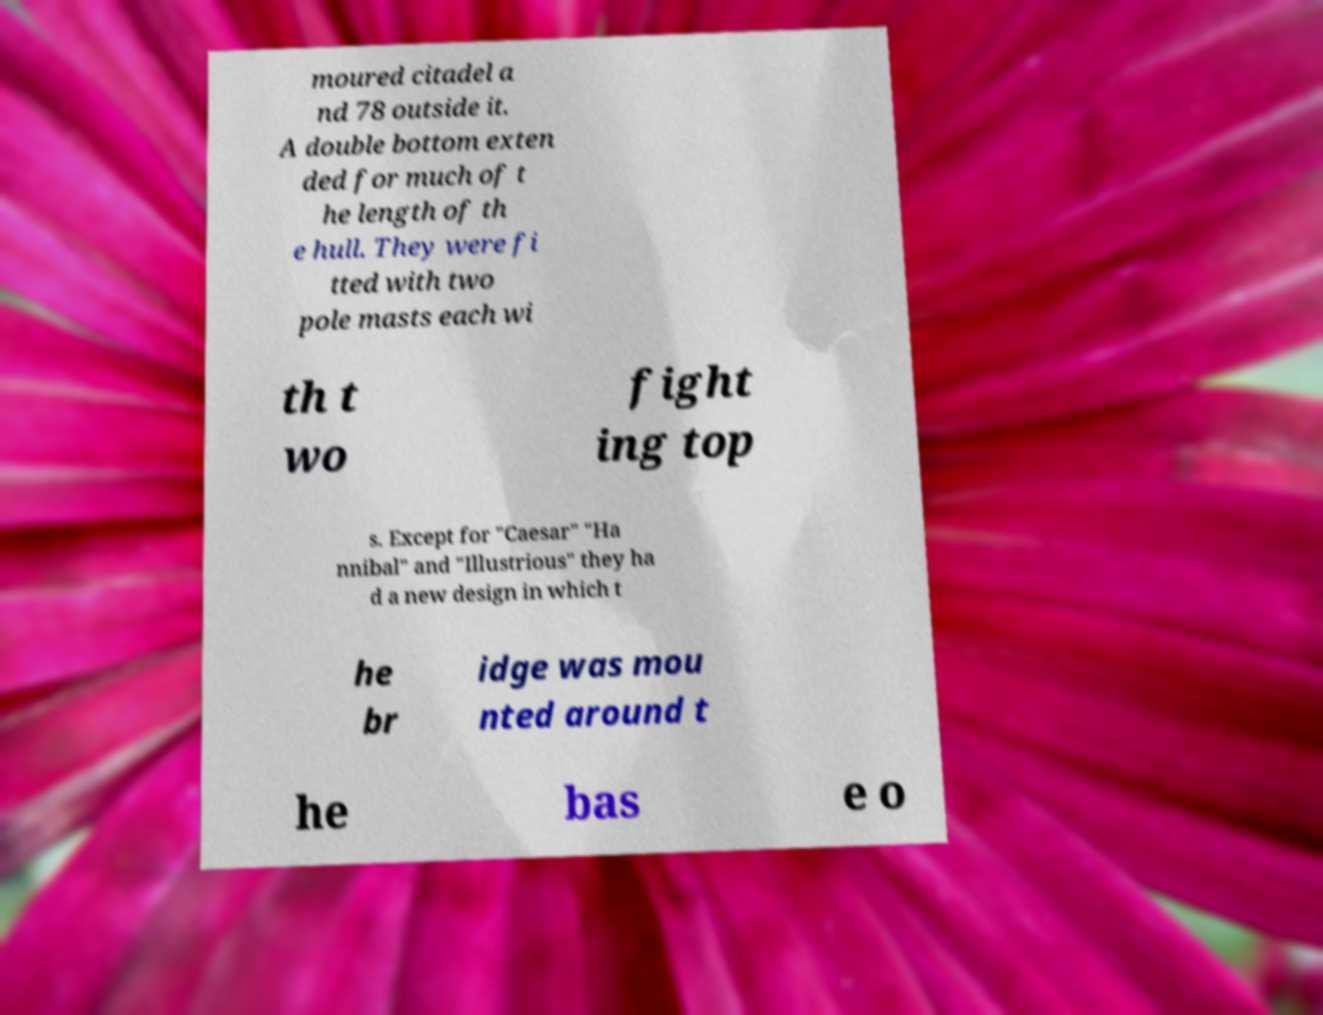For documentation purposes, I need the text within this image transcribed. Could you provide that? moured citadel a nd 78 outside it. A double bottom exten ded for much of t he length of th e hull. They were fi tted with two pole masts each wi th t wo fight ing top s. Except for "Caesar" "Ha nnibal" and "Illustrious" they ha d a new design in which t he br idge was mou nted around t he bas e o 